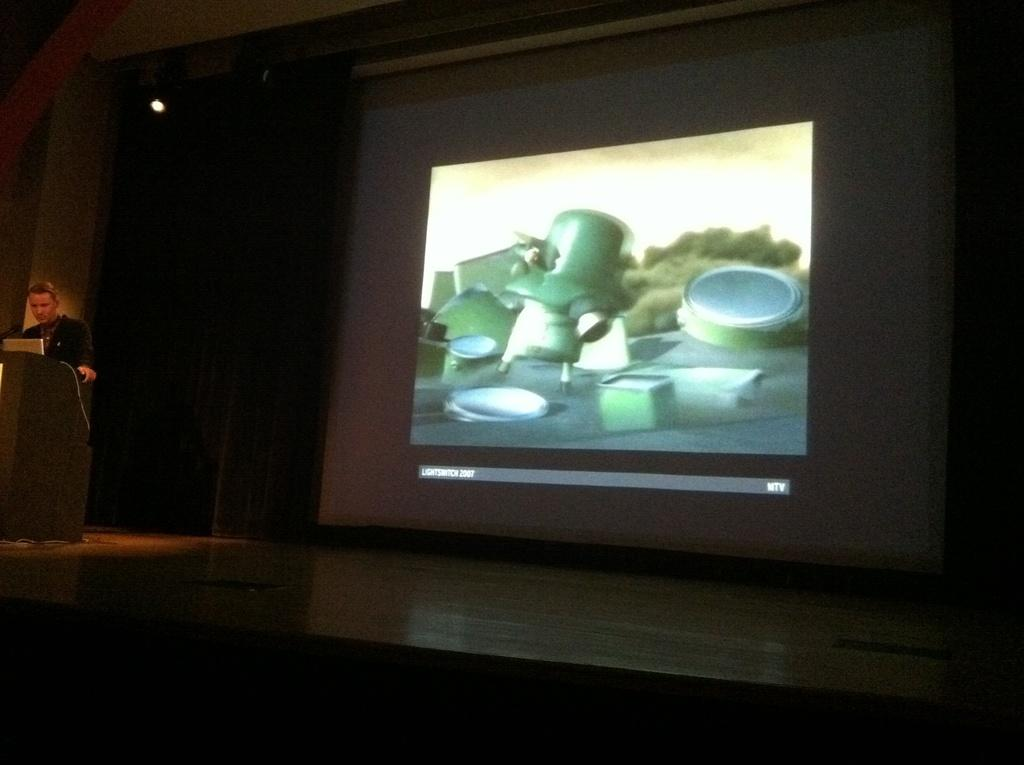What is the person near in the image? There is a person standing near a podium on the left side of the image. What can be seen in the background of the image? There is a screen in the background of the image. What is at the bottom of the image? There is a platform at the bottom of the image. What type of rod is being used by the person on the dock in the image? There is no dock or rod present in the image. What type of glove is the person wearing while standing near the podium in the image? There is no glove mentioned or visible in the image. 